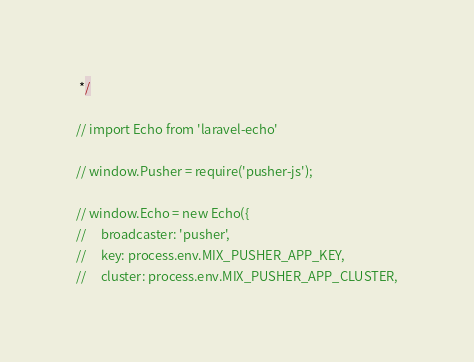<code> <loc_0><loc_0><loc_500><loc_500><_JavaScript_> */

// import Echo from 'laravel-echo'

// window.Pusher = require('pusher-js');

// window.Echo = new Echo({
//     broadcaster: 'pusher',
//     key: process.env.MIX_PUSHER_APP_KEY,
//     cluster: process.env.MIX_PUSHER_APP_CLUSTER,</code> 